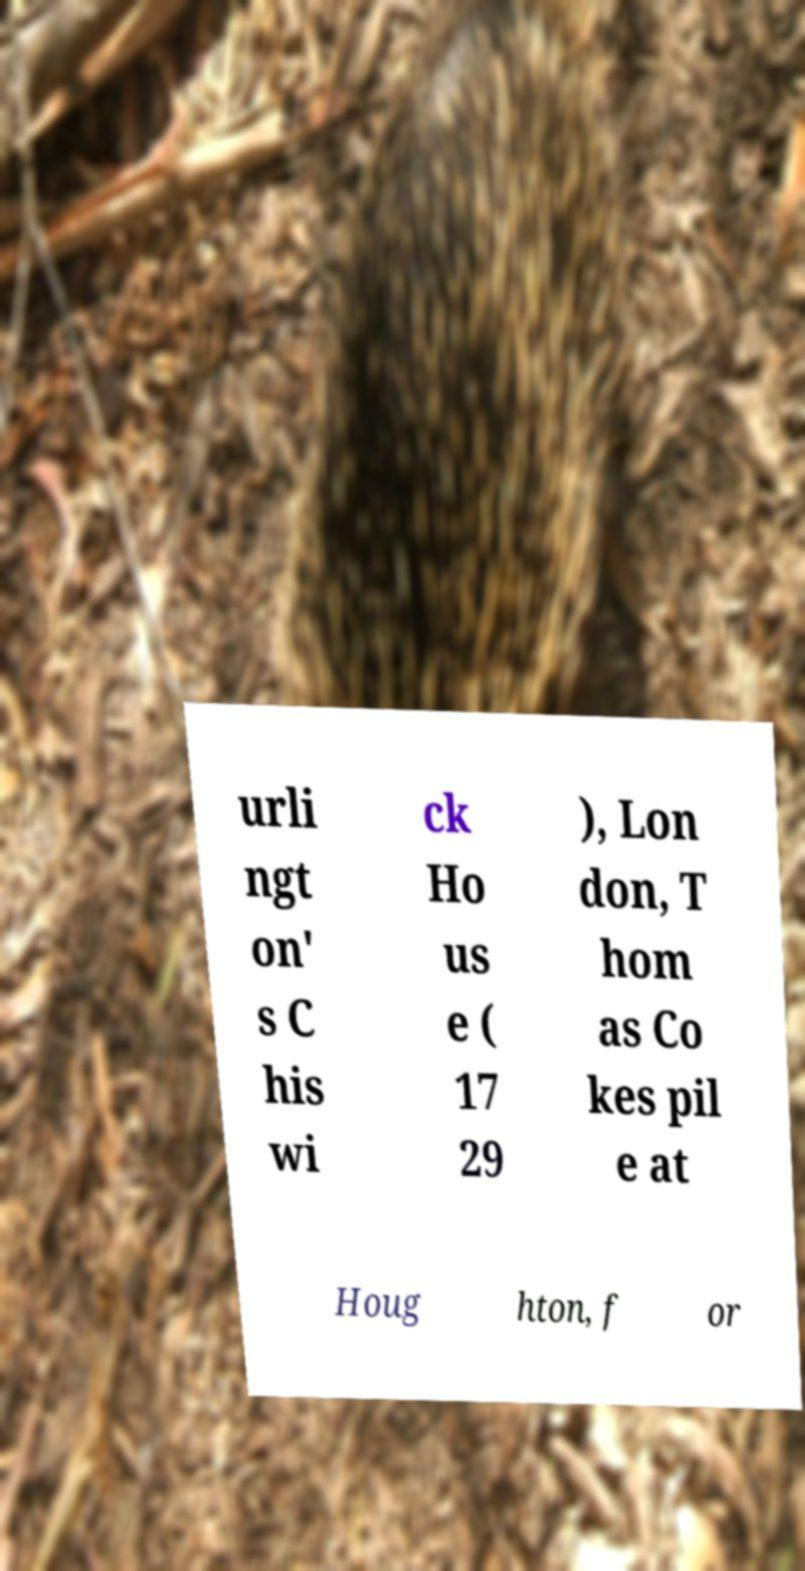Please read and relay the text visible in this image. What does it say? urli ngt on' s C his wi ck Ho us e ( 17 29 ), Lon don, T hom as Co kes pil e at Houg hton, f or 